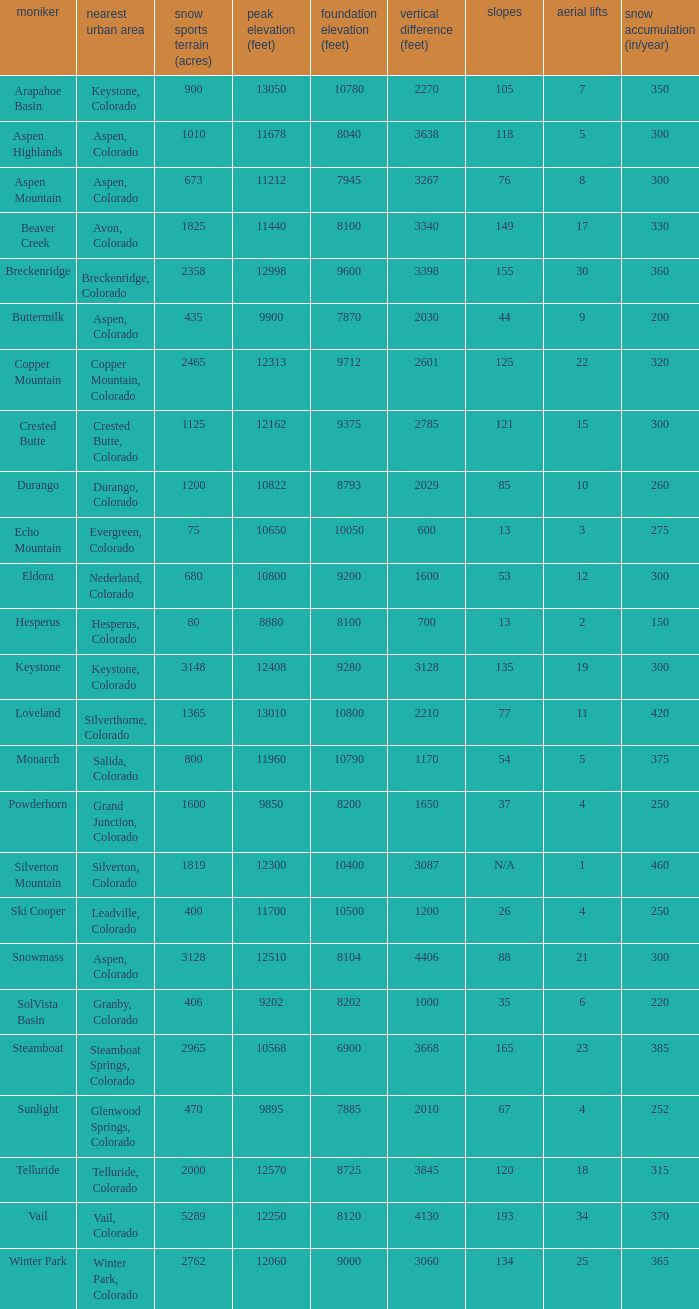If the name is Steamboat, what is the top elevation? 10568.0. 